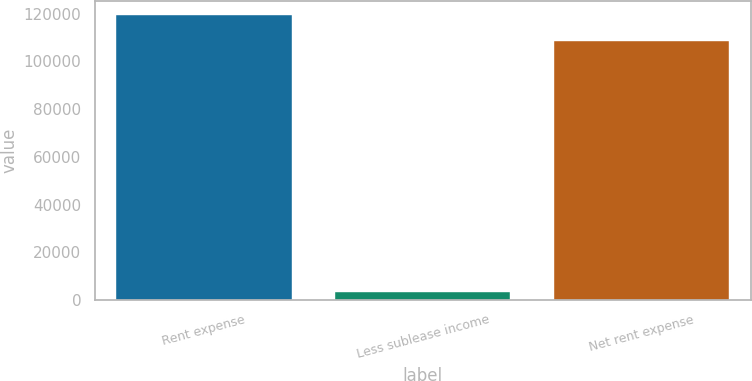Convert chart to OTSL. <chart><loc_0><loc_0><loc_500><loc_500><bar_chart><fcel>Rent expense<fcel>Less sublease income<fcel>Net rent expense<nl><fcel>119199<fcel>3211<fcel>108363<nl></chart> 